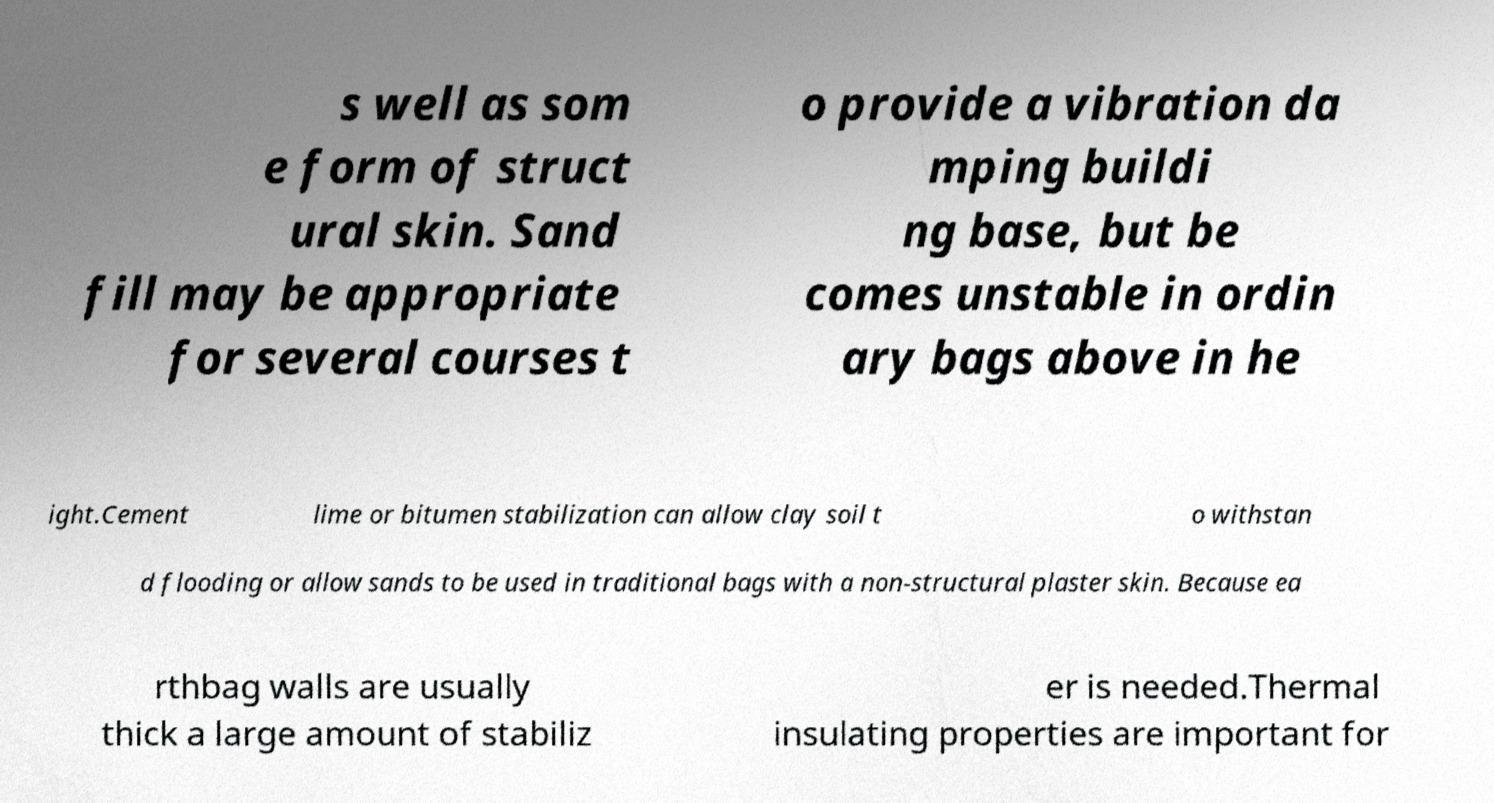Please identify and transcribe the text found in this image. s well as som e form of struct ural skin. Sand fill may be appropriate for several courses t o provide a vibration da mping buildi ng base, but be comes unstable in ordin ary bags above in he ight.Cement lime or bitumen stabilization can allow clay soil t o withstan d flooding or allow sands to be used in traditional bags with a non-structural plaster skin. Because ea rthbag walls are usually thick a large amount of stabiliz er is needed.Thermal insulating properties are important for 